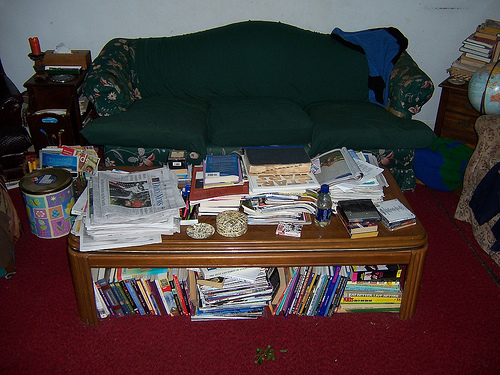<image>
Is there a book on the sofa? No. The book is not positioned on the sofa. They may be near each other, but the book is not supported by or resting on top of the sofa. 